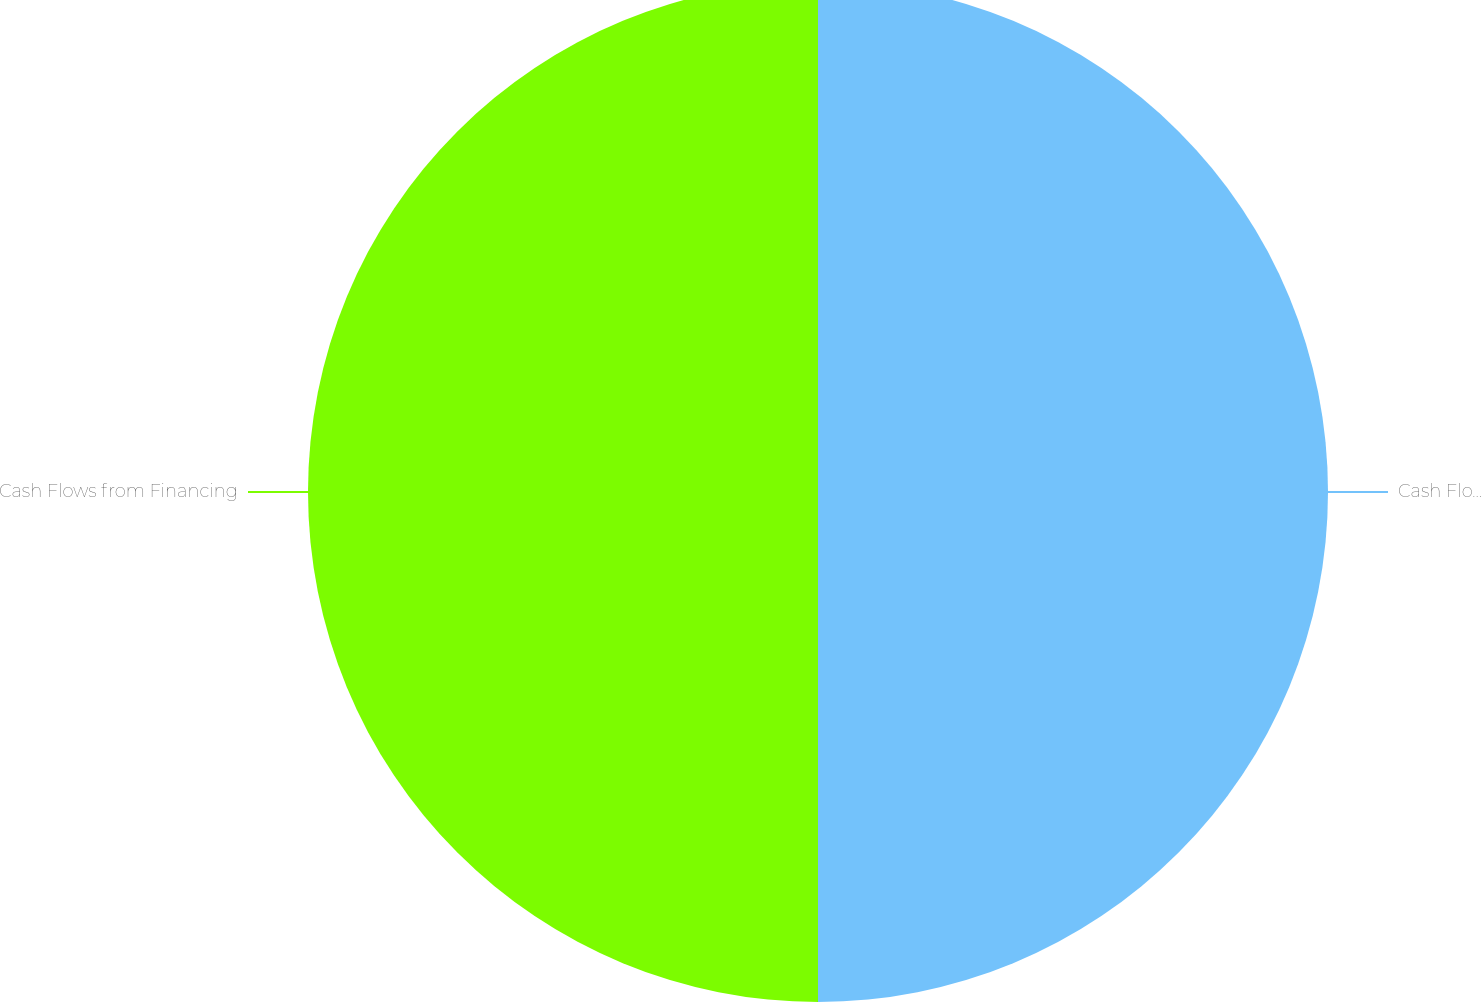<chart> <loc_0><loc_0><loc_500><loc_500><pie_chart><fcel>Cash Flows from Investing<fcel>Cash Flows from Financing<nl><fcel>50.0%<fcel>50.0%<nl></chart> 